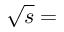<formula> <loc_0><loc_0><loc_500><loc_500>\sqrt { s } =</formula> 